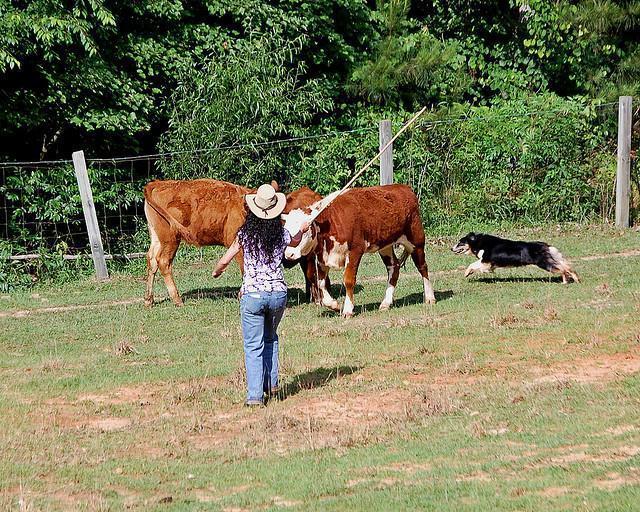How many cows are there?
Give a very brief answer. 2. 